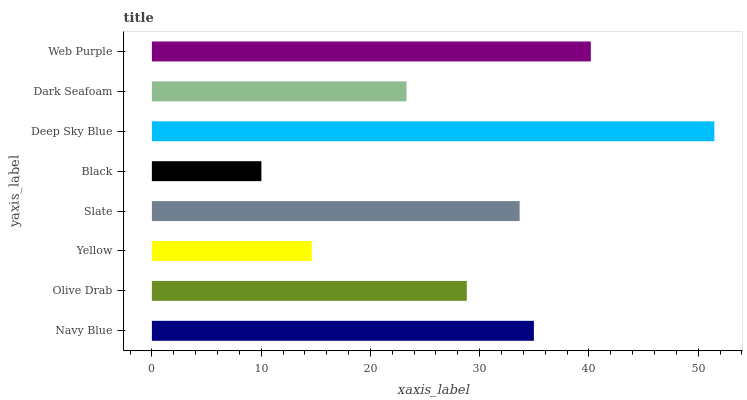Is Black the minimum?
Answer yes or no. Yes. Is Deep Sky Blue the maximum?
Answer yes or no. Yes. Is Olive Drab the minimum?
Answer yes or no. No. Is Olive Drab the maximum?
Answer yes or no. No. Is Navy Blue greater than Olive Drab?
Answer yes or no. Yes. Is Olive Drab less than Navy Blue?
Answer yes or no. Yes. Is Olive Drab greater than Navy Blue?
Answer yes or no. No. Is Navy Blue less than Olive Drab?
Answer yes or no. No. Is Slate the high median?
Answer yes or no. Yes. Is Olive Drab the low median?
Answer yes or no. Yes. Is Dark Seafoam the high median?
Answer yes or no. No. Is Navy Blue the low median?
Answer yes or no. No. 